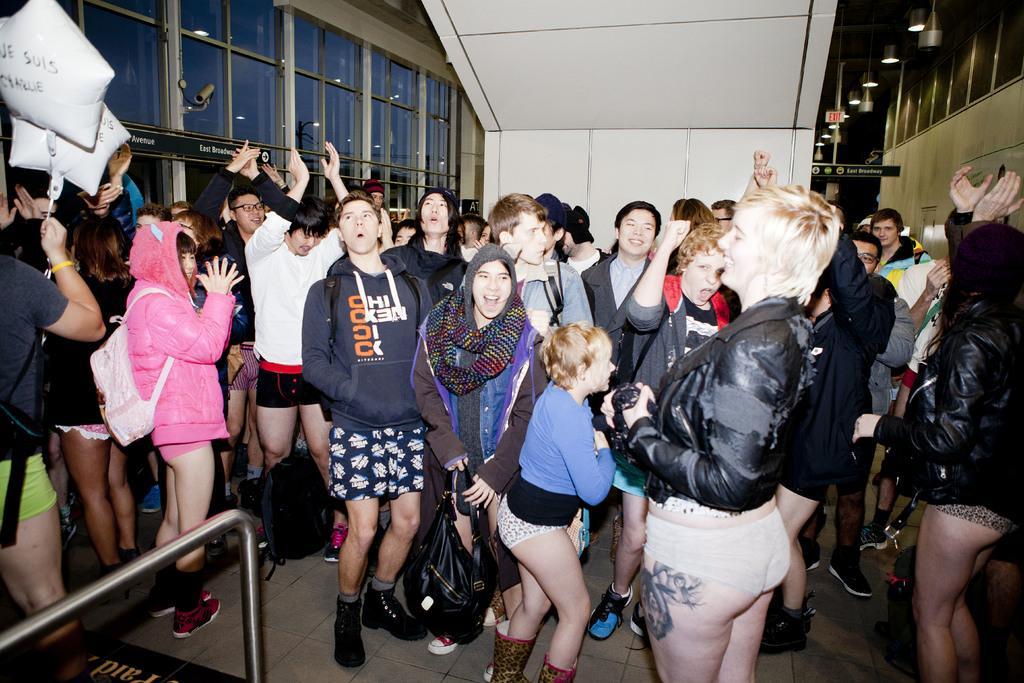Could you give a brief overview of what you see in this image? There are people in the center of the image and there are windows on both the sides, there are lamps and a roof at the top side. There are star balloons in the top left side and there is a rod in the bottom left side of the image. 